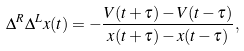<formula> <loc_0><loc_0><loc_500><loc_500>\Delta ^ { R } \Delta ^ { L } x ( t ) = - \frac { V ( t + \tau ) - V ( t - \tau ) } { x ( t + \tau ) - x ( t - \tau ) } ,</formula> 